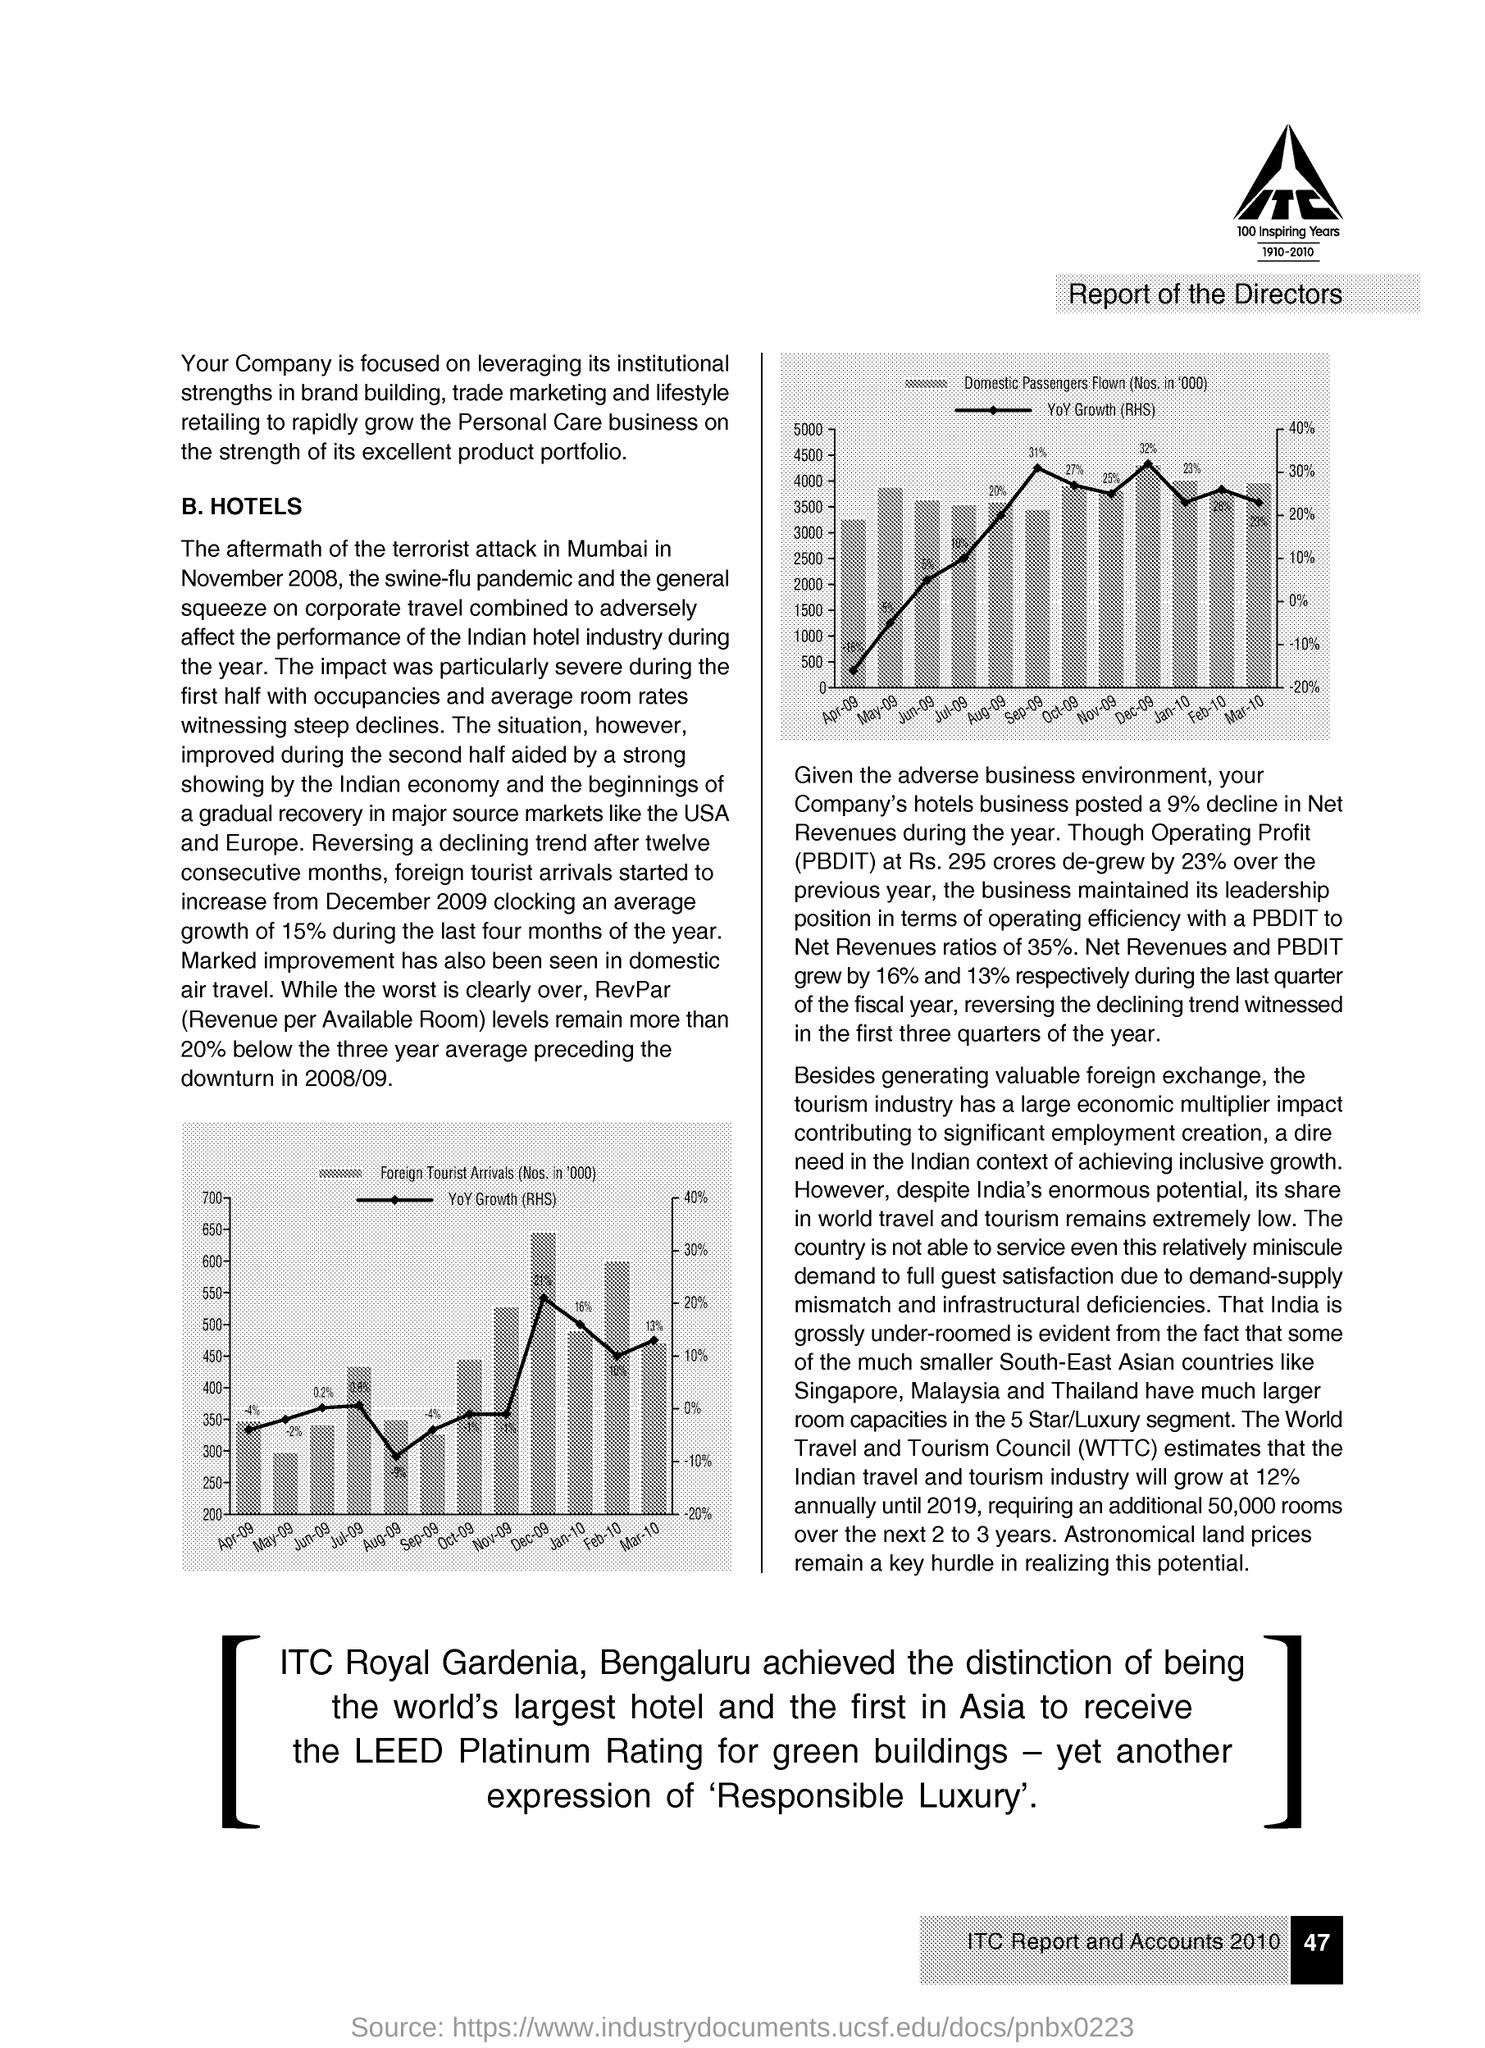Give some essential details in this illustration. WTTC stands for the World Travel and Tourism Council, an international organization dedicated to promoting and advancing the travel and tourism industry. 